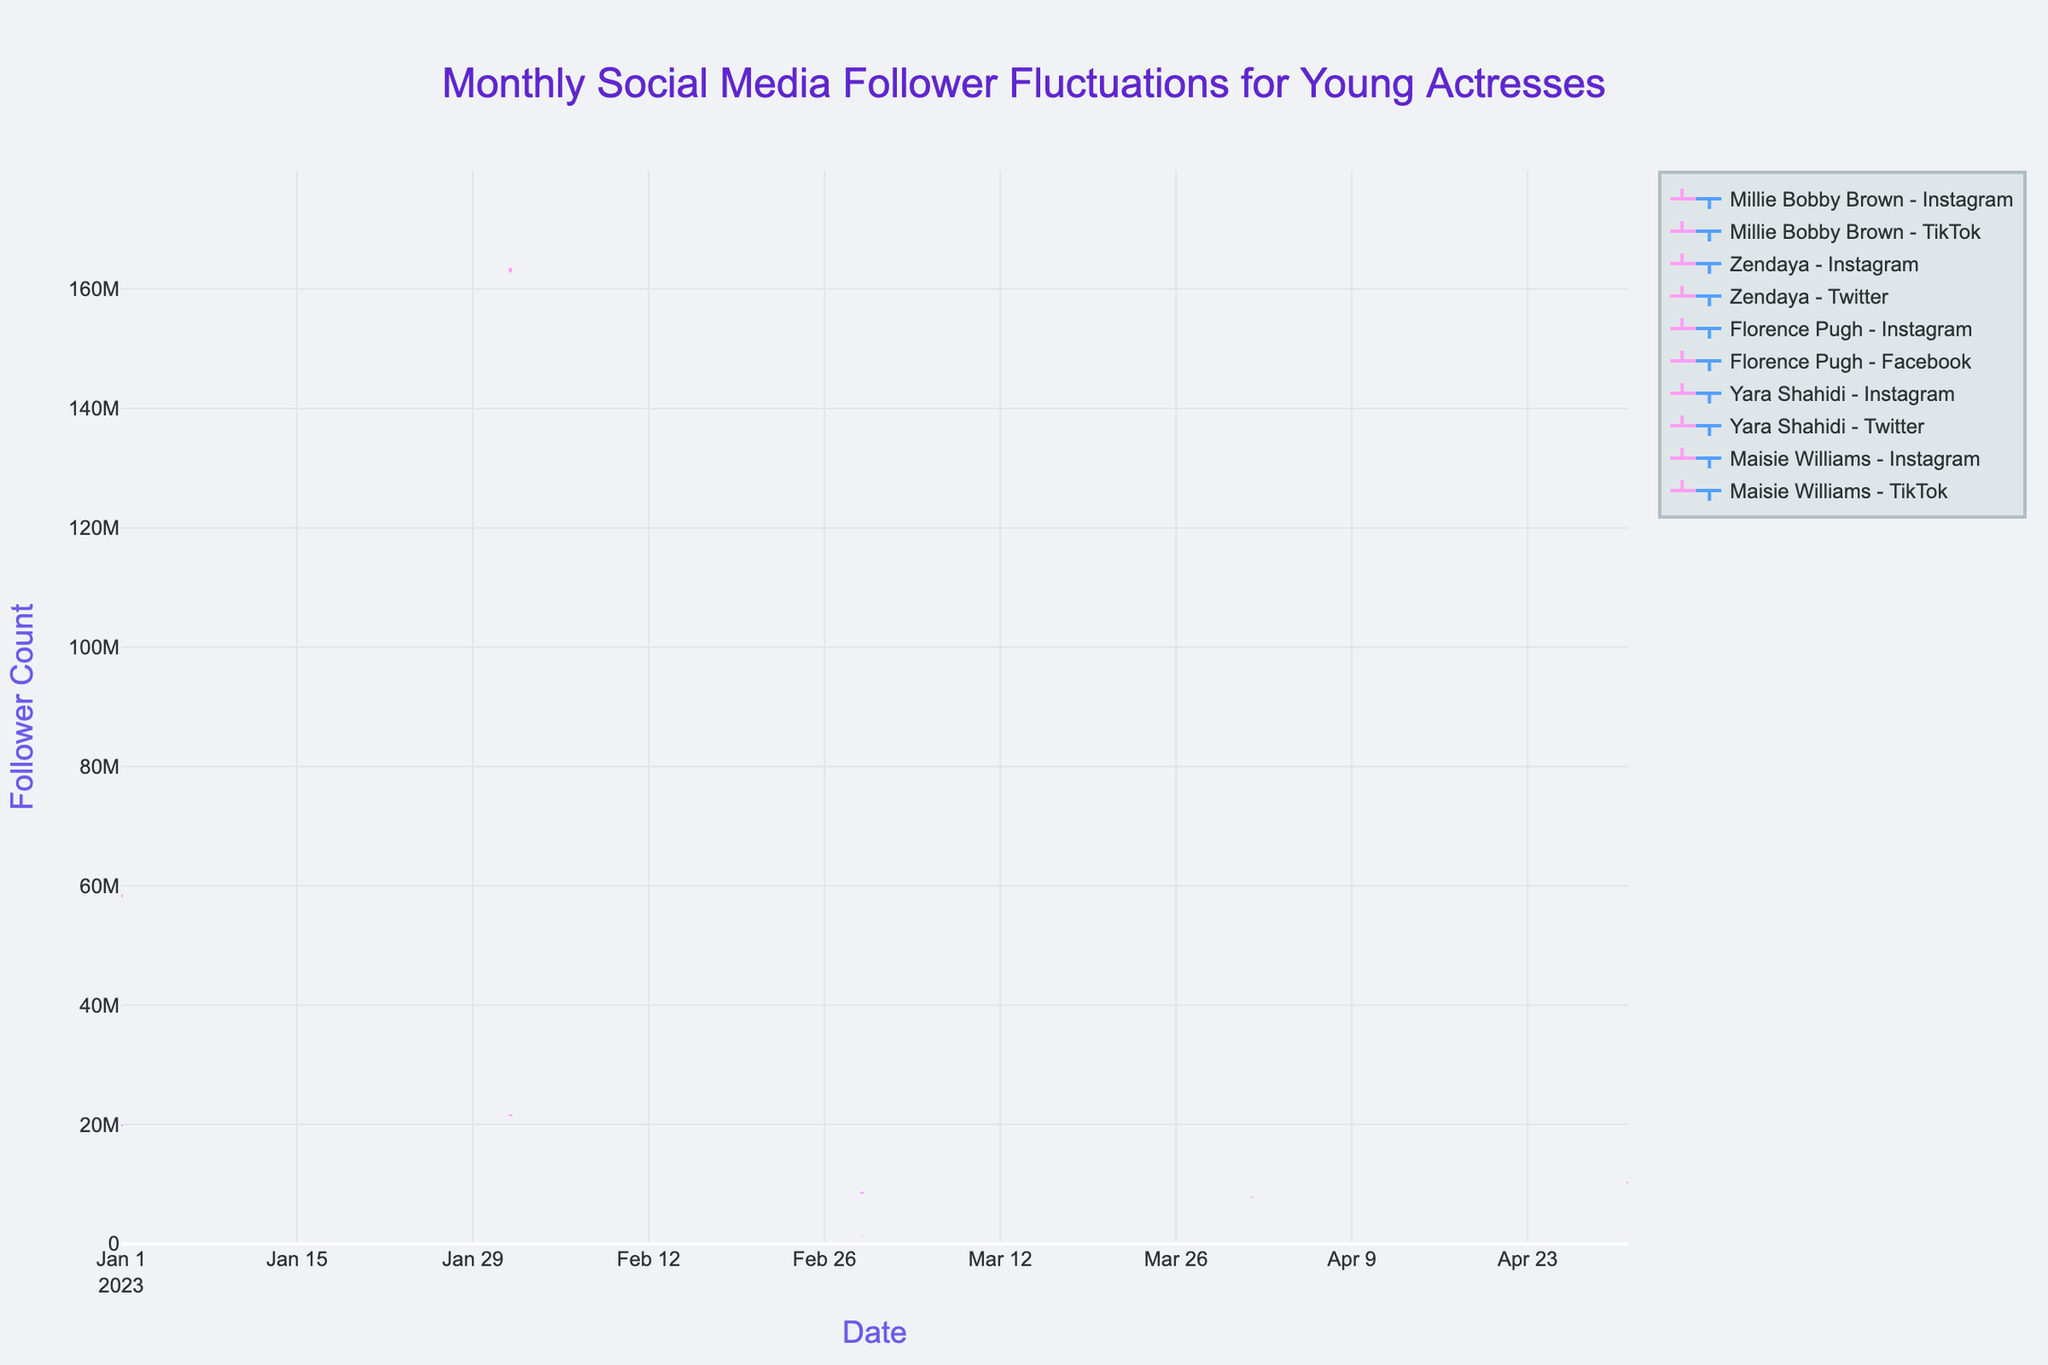How many platforms are being tracked for Millie Bobby Brown in January 2023? There are two OHLC traces for Millie Bobby Brown specifically in January 2023—one for Instagram and one for TikTok.
Answer: 2 What is the highest follower count recorded for Zendaya on Instagram in February 2023? Referring to the highest follower point in February for Zendaya on Instagram, it is 163,500,000.
Answer: 163,500,000 Which actress has the highest closing follower count on Instagram in the entire dataset? Looking at the closing values for each actress on Instagram across all the months, Zendaya in February has the highest closing count at 163,200,000.
Answer: Zendaya What was the lowest follower count recorded for Florence Pugh across all platforms in March 2023? Out of the two platforms (Instagram and Facebook) tracked for Florence Pugh in March, the lowest follower count noted was on Facebook: 1,180,000.
Answer: 1,180,000 Which actress and platform combination has the most significant fluctuation (difference between high and low) in a given month? Calculating the fluctuation for each combination: Millie Bobby Brown's TikTok in January has (20,000,000 - 19,700,000) = 300,000; Zendaya's Twitter in February has (21,700,000 - 21,400,000) = 300,000; Florence Pugh's Instagram in March has (8,700,000 - 8,400,000) = 300,000; Florence Pugh's Facebook in March has (1,250,000 - 1,180,000) = 70,000; Yara Shahidi's Twitter in April has (920,000 - 890,000) = 30,000; Maisie Williams' TikTok in May has (1,550,000 - 1,480,000) = 70,000. Thus, Millie Bobby Brown's TikTok has the most significant fluctuation.
Answer: Millie Bobby Brown - TikTok What is the total increase in follower count for Maisie Williams on Instagram from the lowest to the highest point in May 2023? The increase can be computed as (High - Low) for that month on Instagram: 10,400,000 - 10,150,000 = 250,000.
Answer: 250,000 Compare the closing follower count of Yara Shahidi on Twitter and Instagram for April 2023. Which platform has more? The closing follower count for Yara Shahidi in April: Twitter has 910,000 and Instagram has 7,850,000. Instagram has more.
Answer: Instagram What was the mean follower count (average of open, high, low, close) for Florence Pugh's Instagram in March 2023? Mean can be calculated as (8,500,000 + 8,700,000 + 8,400,000 + 8,600,000) / 4 = 8,550,000.
Answer: 8,550,000 Which month and platform recorded the lowest follower count for Yara Shahidi, and what was this count? For Yara Shahidi, comparing the records for April 2023, Instagram's low point is 7,750,000 and Twitter's low point is 890,000. The lowest is Twitter in April with 890,000.
Answer: April 2023, Twitter, 890,000 